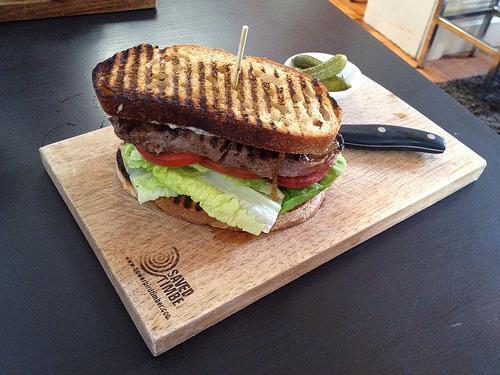How many knives?
Give a very brief answer. 1. 